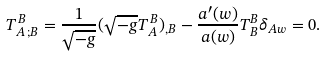Convert formula to latex. <formula><loc_0><loc_0><loc_500><loc_500>T _ { A \, ; B } ^ { \, B } = \frac { 1 } { \sqrt { - g } } ( \sqrt { - g } T _ { A } ^ { \, B } ) _ { , B } - \frac { a ^ { \prime } ( w ) } { a ( w ) } T _ { B } ^ { B } \delta _ { A w } = 0 .</formula> 